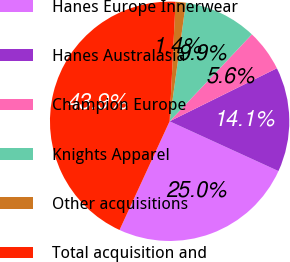Convert chart. <chart><loc_0><loc_0><loc_500><loc_500><pie_chart><fcel>Hanes Europe Innerwear<fcel>Hanes Australasia<fcel>Champion Europe<fcel>Knights Apparel<fcel>Other acquisitions<fcel>Total acquisition and<nl><fcel>25.05%<fcel>14.14%<fcel>5.63%<fcel>9.89%<fcel>1.38%<fcel>43.92%<nl></chart> 